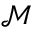<formula> <loc_0><loc_0><loc_500><loc_500>\mathcal { M }</formula> 